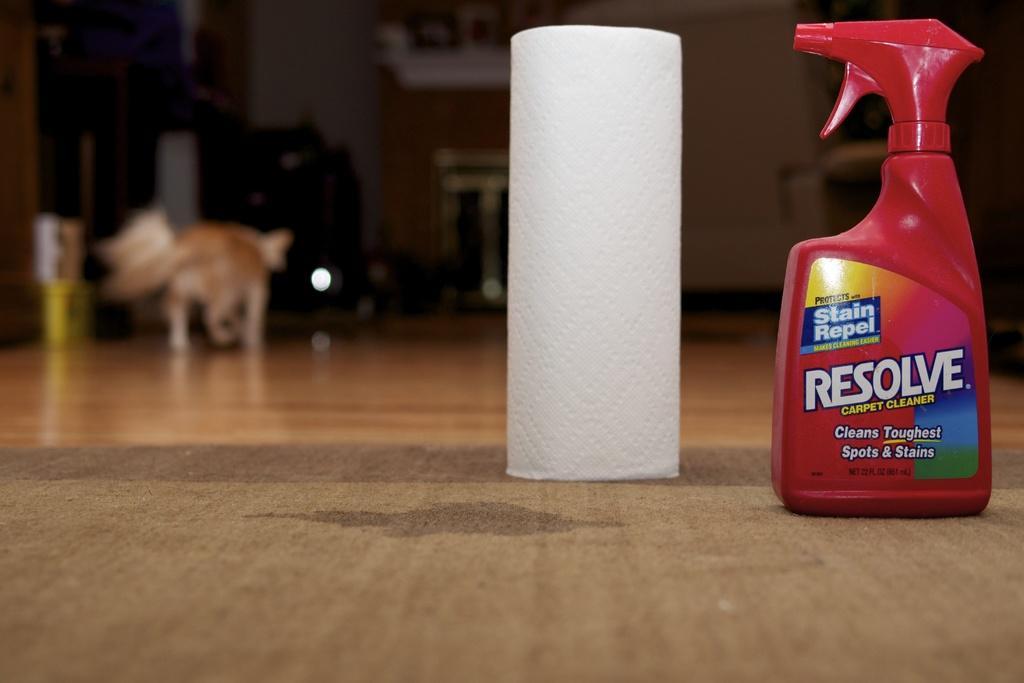How would you summarize this image in a sentence or two? On the right side, we see a plastic bottle in red color. On the bottle, it is written as "RESOLVED". Beside that, we see the tissue roll. At the bottom, we see the carpet and the wooden floor. On the left side, we see a dog. Beside that, we see a yellow color box and a cupboard. In the background, it is blurred. This picture is clicked inside the room. 